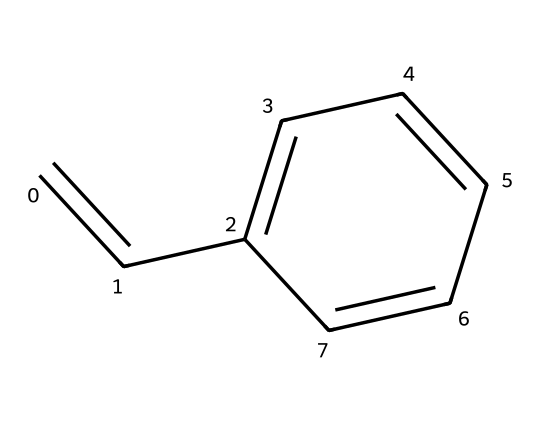What is the molecular formula of styrene? To find the molecular formula, we count the carbon (C) and hydrogen (H) atoms in the structure. The SMILES notation indicates 8 carbon atoms and 8 hydrogen atoms, thus the formula is C8H8.
Answer: C8H8 How many double bonds are in styrene? By examining the structure, we can identify that there is one double bond present between the first two carbon atoms in the C=CC fragment.
Answer: 1 What type of chemical is styrene categorized as? Styrene is categorized as a monomer because it is a single repeating unit that can polymerize to form polystyrene.
Answer: monomer Which part of styrene provides its aromatic properties? The presence of the benzene ring structure (C1=CC=CC=C1) in styrene is responsible for its aromatic properties, characterized by alternating double bonds and a stable ring.
Answer: benzene ring How many rings are present in the chemical structure of styrene? The structure contains one cyclic component, which is the benzene ring, making it a single ring structure.
Answer: 1 What type of bonding is prominently featured in styrene? Styrene features both single and double bonding, where the double bond (C=C) is particularly significant for its reactivity in polymerization processes.
Answer: double and single bonding 